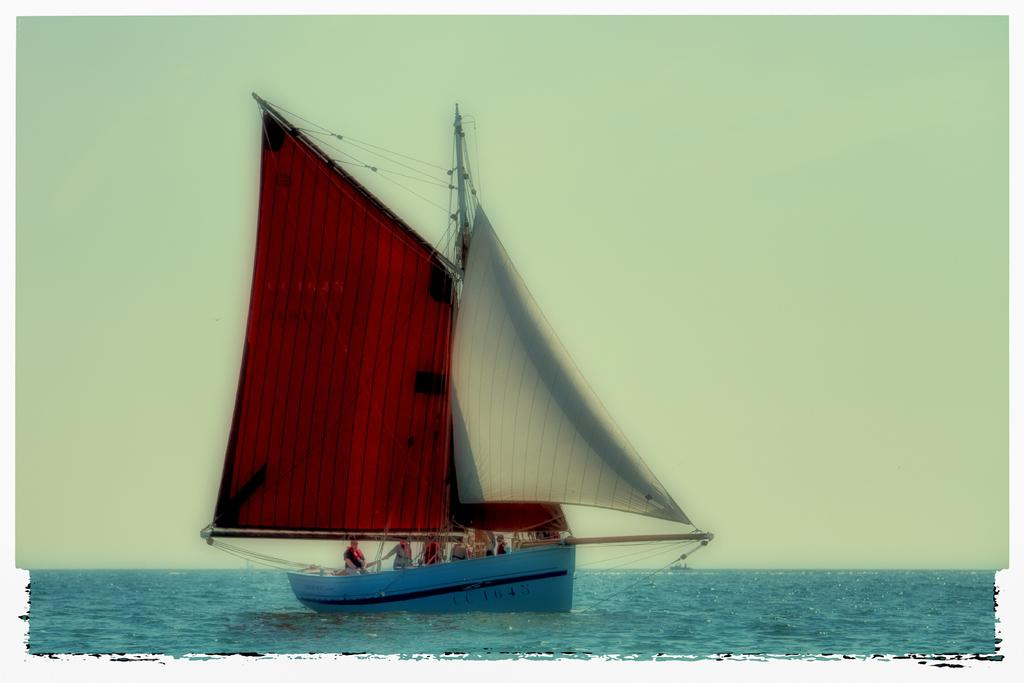What is the main setting of the image? The main setting of the image is the sea. What is on the sea in the image? There is a boat on the sea in the image. Who or what is inside the boat? There are people in the boat. What can be seen in the background of the image? The sky is visible in the background of the image. What type of crayon is being used to draw on the boat in the image? There is no crayon or drawing activity present in the image; it features a boat with people on the sea. 